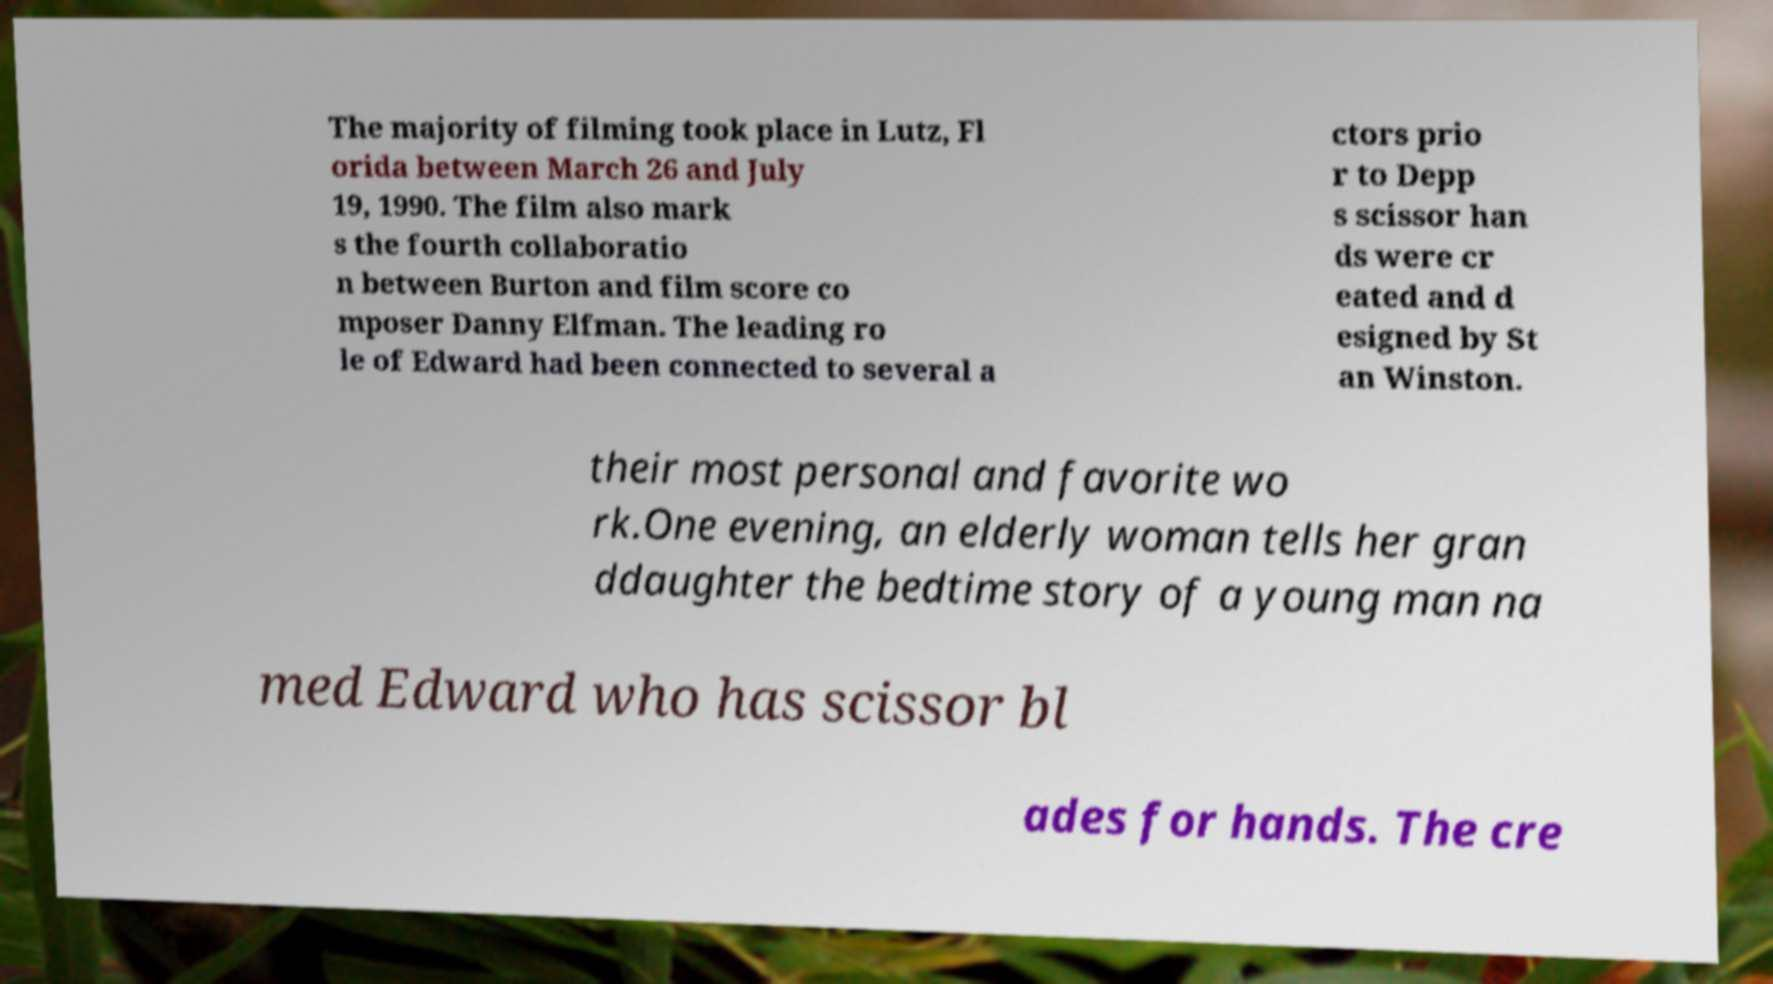Could you assist in decoding the text presented in this image and type it out clearly? The majority of filming took place in Lutz, Fl orida between March 26 and July 19, 1990. The film also mark s the fourth collaboratio n between Burton and film score co mposer Danny Elfman. The leading ro le of Edward had been connected to several a ctors prio r to Depp s scissor han ds were cr eated and d esigned by St an Winston. their most personal and favorite wo rk.One evening, an elderly woman tells her gran ddaughter the bedtime story of a young man na med Edward who has scissor bl ades for hands. The cre 